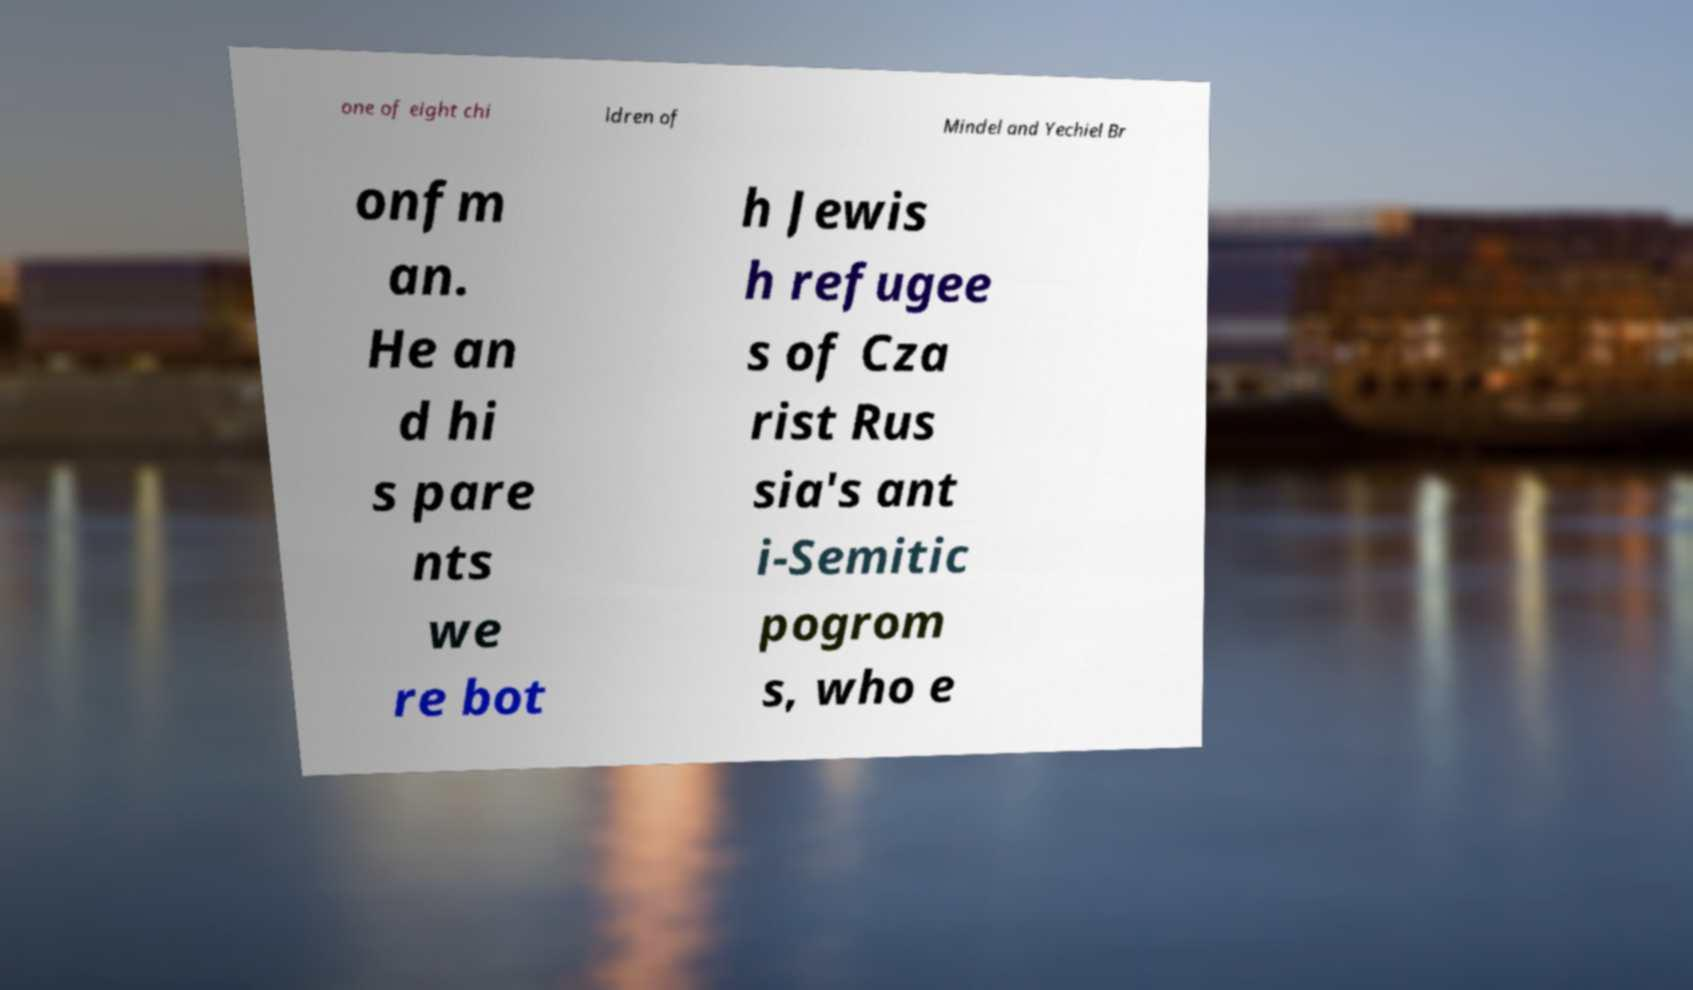Could you extract and type out the text from this image? one of eight chi ldren of Mindel and Yechiel Br onfm an. He an d hi s pare nts we re bot h Jewis h refugee s of Cza rist Rus sia's ant i-Semitic pogrom s, who e 